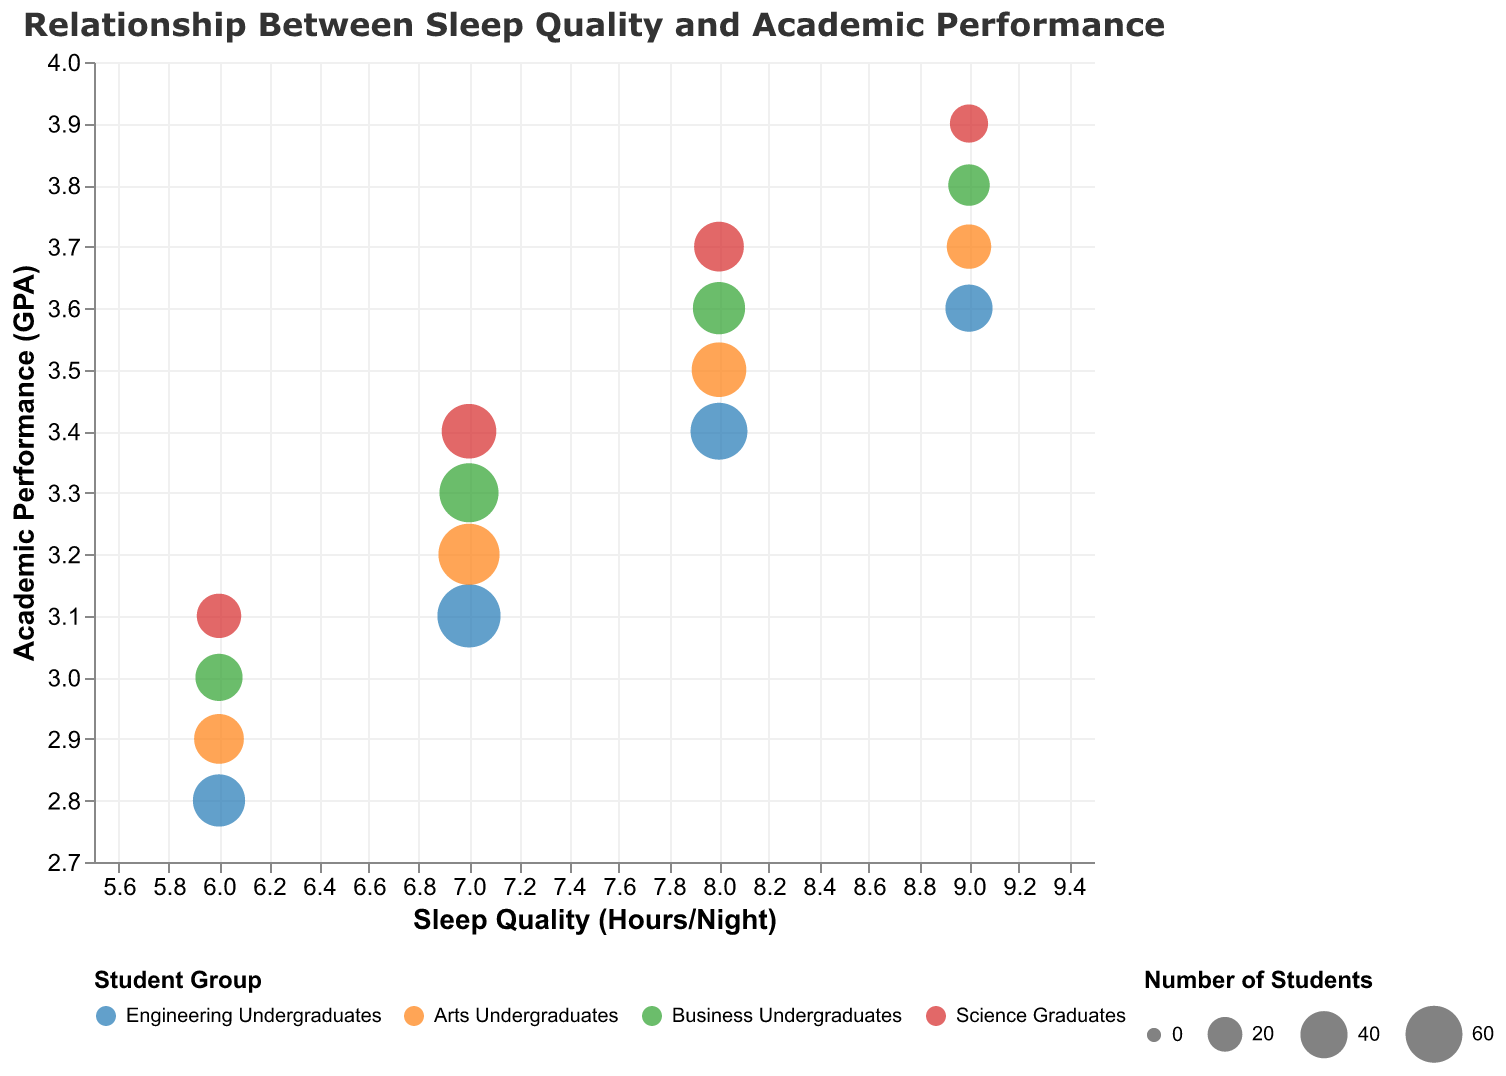What's the title of the chart? The title is located at the top of the chart and it reads: "Relationship Between Sleep Quality and Academic Performance".
Answer: Relationship Between Sleep Quality and Academic Performance What does the x-axis represent? The x-axis is labeled "Sleep Quality (Hours/Night)", indicating it represents the number of hours students sleep per night.
Answer: Sleep Quality (Hours/Night) Which student group has the highest GPA with 8 hours of sleep? Looking at the chart, identify the student group with the highest GPA among those with 8 hours of sleep. Science Graduates have a GPA of 3.7, which is the highest.
Answer: Science Graduates How many students are there in the Engineering Undergraduates group who sleep 7 hours per night? Identify the data point for Engineering Undergraduates with 7 hours of sleep. The tooltip or bubble size shows that there are 75 students in this group.
Answer: 75 Which student group shows the lowest academic performance with 6 hours of sleep? Look at the bubbles corresponding to 6 hours of sleep and find the group with the lowest GPA. Engineering Undergraduates have the lowest GPA of 2.8.
Answer: Engineering Undergraduates How does sleep quality affect academic performance in Business Undergraduates? Examine the GPA of Business Undergraduates as sleep hours increase. It shows a positive trend where GPA improves from 3.0 at 6 hours to 3.8 at 9 hours of sleep.
Answer: GPA improves with more sleep What is the relationship between the number of students and sleep quality in Arts Undergraduates? Locate the bubbles for Arts Undergraduates and summarize the trend. The number of students decreases as sleep quality increases, from 45 students at 6 hours to 35 at 9 hours.
Answer: Number decreases with more sleep Compare the academic performance of students who sleep 8 hours per night across different groups. Identify the GPAs for each student group at 8 hours of sleep. Engineering Undergraduates: 3.4, Arts Undergraduates: 3.5, Business Undergraduates: 3.6, Science Graduates: 3.7. Science Graduates have the highest GPA.
Answer: Science Graduates: 3.7 What can you infer about the relationship between sleep quality and academic performance for Science Graduates? Look at the trend line for Science Graduates. The GPA increases consistently from 3.1 at 6 hours to 3.9 at 9 hours.
Answer: Higher sleep quality correlates with better academic performance What is the general trend in academic performance as sleep quality improves across all student groups? Observe the overall direction of GPA values as sleep hours increase. Generally, the GPA improves as sleep quality (hours of sleep) increases for all student groups.
Answer: GPA improves with more sleep 